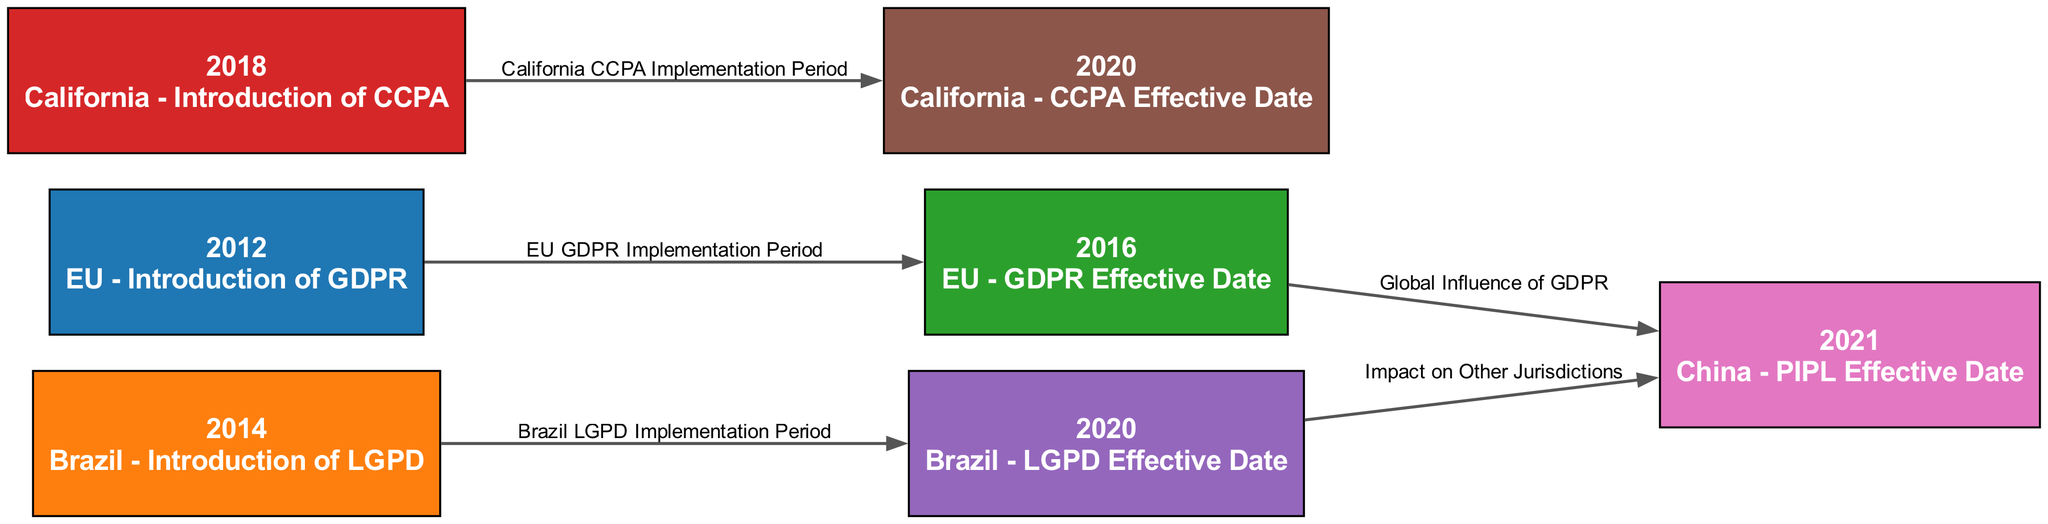What year was the GDPR introduced in the EU? The diagram indicates that the GDPR was introduced in the EU in the year labeled "2012". This is the direct representation of the node corresponding to that event.
Answer: 2012 What significant event occurred in California in 2018? Referring to the diagram, the node labeled "2018" indicates that California introduced the CCPA. This is a specific detail connected to the California timeline.
Answer: Introduction of CCPA How many major data privacy regulations are represented in the diagram? By counting the nodes present in the diagram, we see there are seven distinct nodes. Each node corresponds to a significant regulation or event highlighted in the timeline.
Answer: 7 What relationship exists between the GDPR Effective Date and the PIPL Effective Date? The diagram displays an edge indicating a connection from the GDPR Effective Date node (2016) to the PIPL Effective Date node (2021) labeled "Global Influence of GDPR". This suggests that the GDPR had a significant influence, impacting the timeline of the PIPL's effectiveness.
Answer: Global Influence of GDPR Which regulation has an implementation period leading to its effective date in Brazil? The edge in the diagram from the node for the introduction of LGPD in 2014 to its effective date in 2020 represents the specific implementation period for the Brazilian regulation. This is clearly marked in the diagram.
Answer: Brazil LGPD Implementation Period What year did the CCPA become effective? The diagram presents a node for California indicating that the CCPA became effective in the year 2020, as noted directly under the corresponding label in the diagram.
Answer: 2020 How many links are there in total between the regulations presented in this diagram? By examining the edges connecting the nodes, we find five distinct connections, which represent the relationships and implementation periods among the various regulations discussed.
Answer: 5 What is the impact labeled between LGPD and PIPL in this timeline? In the diagram, there is an edge from the LGPD effective date to the PIPL effective date labeled "Impact on Other Jurisdictions", signifying that the Brazilian regulation influenced the development of other regulations, including PIPL.
Answer: Impact on Other Jurisdictions What node is directly connected to the "2020" node with respect to California regulations? The edge in the diagram shows a connection from the introduction of the CCPA in 2018 to its effective date in 2020, highlighting the progression and compliance timeline for California data privacy law.
Answer: California CCPA Implementation Period 